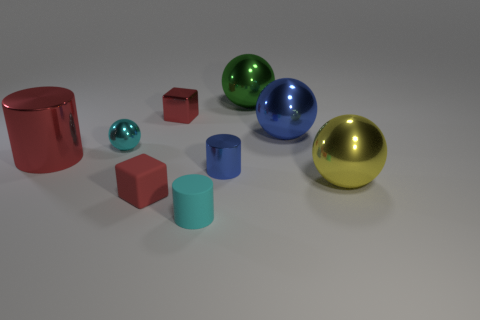How many red blocks must be subtracted to get 1 red blocks? 1 Subtract all cubes. How many objects are left? 7 Subtract 1 blue cylinders. How many objects are left? 8 Subtract all rubber blocks. Subtract all cyan matte cylinders. How many objects are left? 7 Add 1 big shiny objects. How many big shiny objects are left? 5 Add 8 tiny red rubber things. How many tiny red rubber things exist? 9 